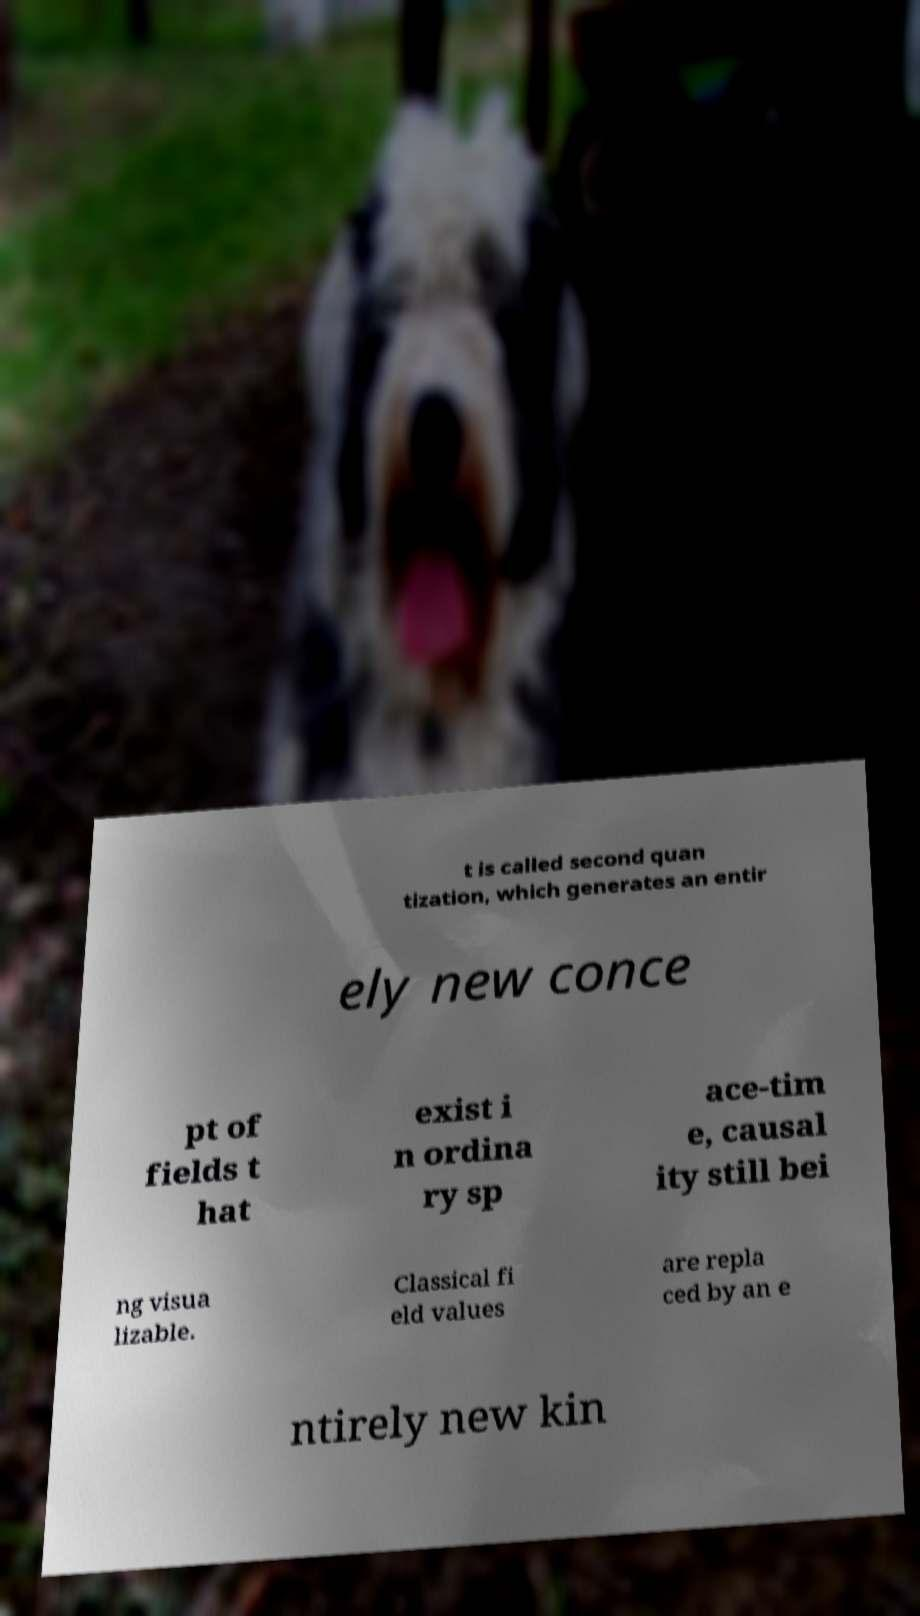I need the written content from this picture converted into text. Can you do that? t is called second quan tization, which generates an entir ely new conce pt of fields t hat exist i n ordina ry sp ace-tim e, causal ity still bei ng visua lizable. Classical fi eld values are repla ced by an e ntirely new kin 